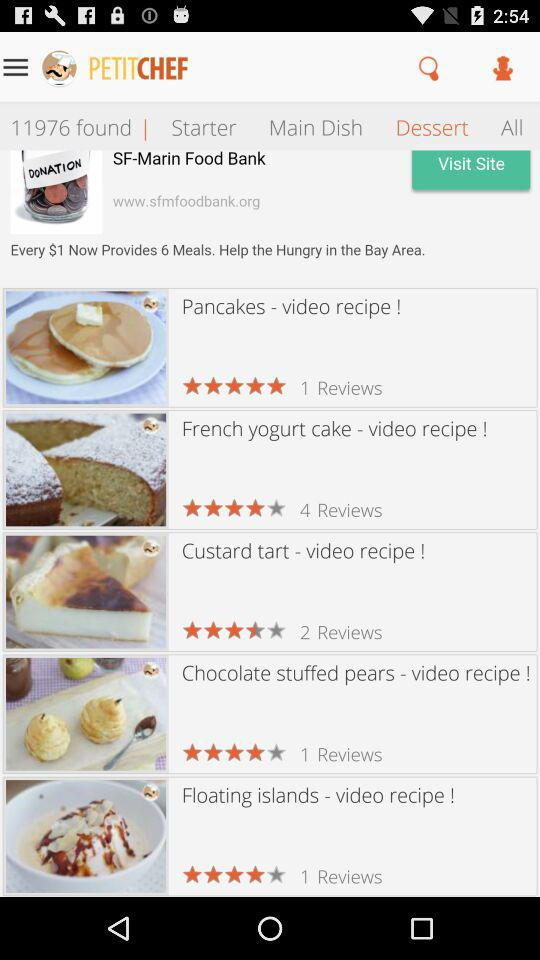Which tab is selected? The selected tab is "Dessert". 